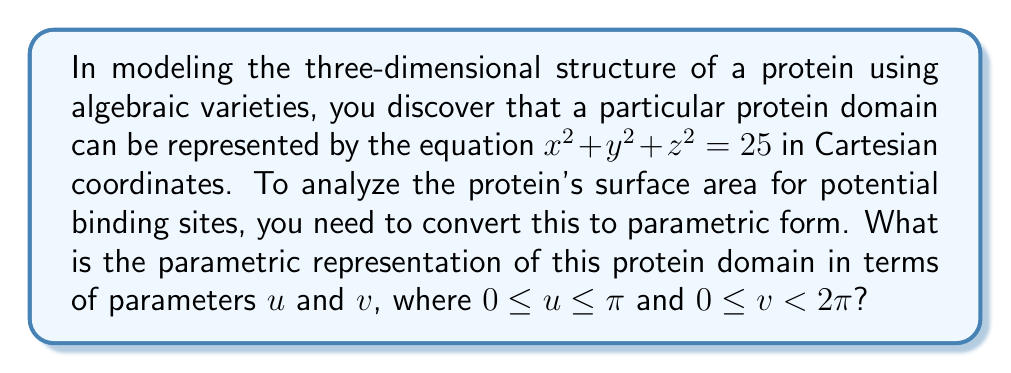Teach me how to tackle this problem. To convert the given equation $x^2 + y^2 + z^2 = 25$ to parametric form, we can follow these steps:

1) Recognize that this equation represents a sphere with radius $r = 5$.

2) For a sphere, we can use spherical coordinates with two parameters:
   $u$ (polar angle) and $v$ (azimuthal angle).

3) The general parametric equations for a sphere are:
   $$x = r \sin u \cos v$$
   $$y = r \sin u \sin v$$
   $$z = r \cos u$$

4) In this case, $r = 5$, so we substitute this value:
   $$x = 5 \sin u \cos v$$
   $$y = 5 \sin u \sin v$$
   $$z = 5 \cos u$$

5) The domain for the parameters is:
   $0 \leq u \leq \pi$ (covers the full range from north to south pole)
   $0 \leq v < 2\pi$ (covers a full rotation around the z-axis)

This parametric representation allows us to describe any point on the protein domain's surface using two parameters, which is useful for analyzing potential binding sites in three-dimensional space.
Answer: $x = 5 \sin u \cos v$, $y = 5 \sin u \sin v$, $z = 5 \cos u$, where $0 \leq u \leq \pi$ and $0 \leq v < 2\pi$ 